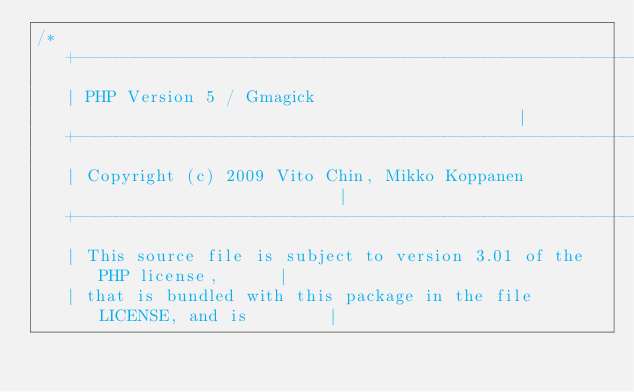<code> <loc_0><loc_0><loc_500><loc_500><_C_>/*
   +----------------------------------------------------------------------+
   | PHP Version 5 / Gmagick	                                          |
   +----------------------------------------------------------------------+
   | Copyright (c) 2009 Vito Chin, Mikko Koppanen                         |
   +----------------------------------------------------------------------+
   | This source file is subject to version 3.01 of the PHP license,      |
   | that is bundled with this package in the file LICENSE, and is        |</code> 